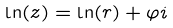<formula> <loc_0><loc_0><loc_500><loc_500>\ln ( z ) = \ln ( r ) + \varphi i</formula> 